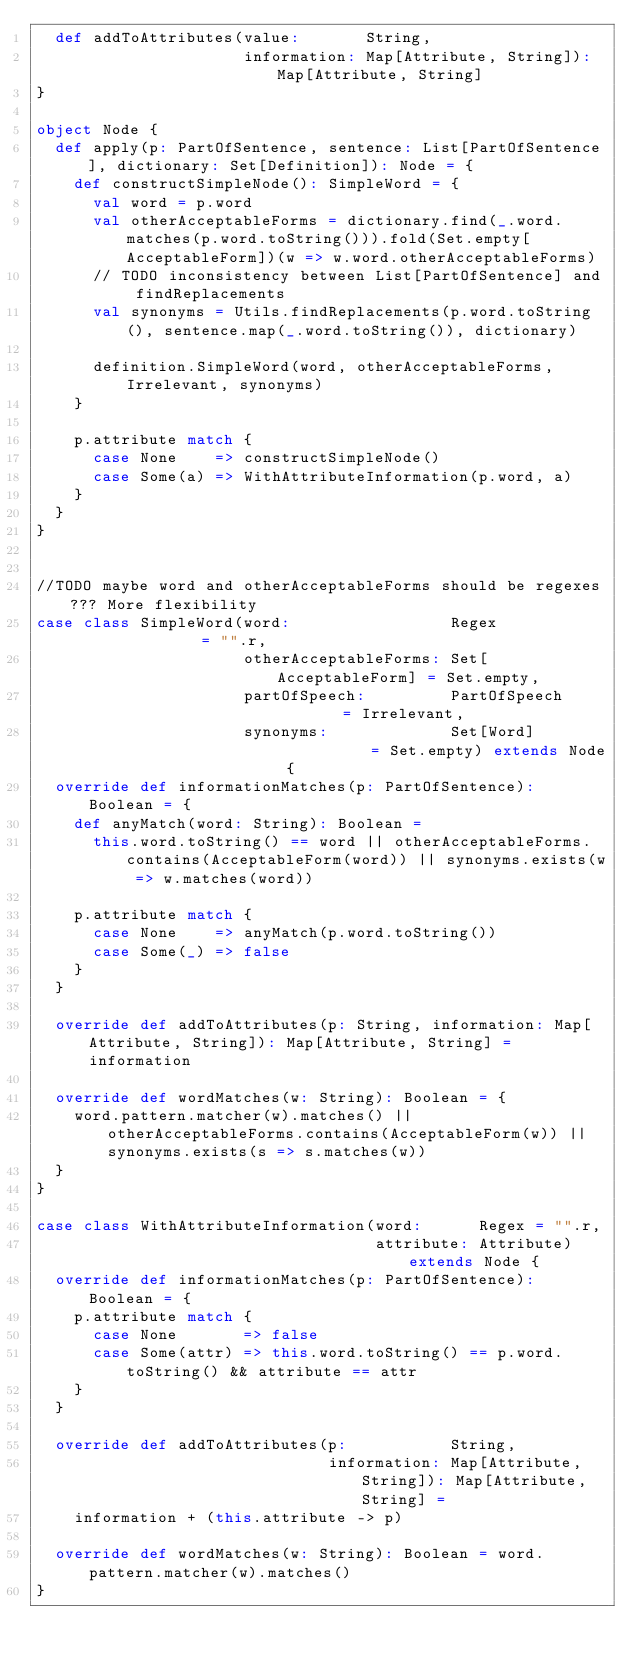Convert code to text. <code><loc_0><loc_0><loc_500><loc_500><_Scala_>  def addToAttributes(value:       String,
                      information: Map[Attribute, String]): Map[Attribute, String]
}

object Node {
  def apply(p: PartOfSentence, sentence: List[PartOfSentence], dictionary: Set[Definition]): Node = {
    def constructSimpleNode(): SimpleWord = {
      val word = p.word
      val otherAcceptableForms = dictionary.find(_.word.matches(p.word.toString())).fold(Set.empty[AcceptableForm])(w => w.word.otherAcceptableForms)
      // TODO inconsistency between List[PartOfSentence] and findReplacements
      val synonyms = Utils.findReplacements(p.word.toString(), sentence.map(_.word.toString()), dictionary)

      definition.SimpleWord(word, otherAcceptableForms, Irrelevant, synonyms)
    }

    p.attribute match {
      case None    => constructSimpleNode()
      case Some(a) => WithAttributeInformation(p.word, a)
    }
  }
}


//TODO maybe word and otherAcceptableForms should be regexes??? More flexibility
case class SimpleWord(word:                 Regex               = "".r,
                      otherAcceptableForms: Set[AcceptableForm] = Set.empty,
                      partOfSpeech:         PartOfSpeech        = Irrelevant,
                      synonyms:             Set[Word]           = Set.empty) extends Node {
  override def informationMatches(p: PartOfSentence): Boolean = {
    def anyMatch(word: String): Boolean =
      this.word.toString() == word || otherAcceptableForms.contains(AcceptableForm(word)) || synonyms.exists(w => w.matches(word))

    p.attribute match {
      case None    => anyMatch(p.word.toString())
      case Some(_) => false
    }
  }

  override def addToAttributes(p: String, information: Map[Attribute, String]): Map[Attribute, String] = information

  override def wordMatches(w: String): Boolean = {
    word.pattern.matcher(w).matches() || otherAcceptableForms.contains(AcceptableForm(w)) || synonyms.exists(s => s.matches(w))
  }
}

case class WithAttributeInformation(word:      Regex = "".r,
                                    attribute: Attribute) extends Node {
  override def informationMatches(p: PartOfSentence): Boolean = {
    p.attribute match {
      case None       => false
      case Some(attr) => this.word.toString() == p.word.toString() && attribute == attr
    }
  }

  override def addToAttributes(p:           String,
                               information: Map[Attribute, String]): Map[Attribute, String] =
    information + (this.attribute -> p)

  override def wordMatches(w: String): Boolean = word.pattern.matcher(w).matches()
}


</code> 